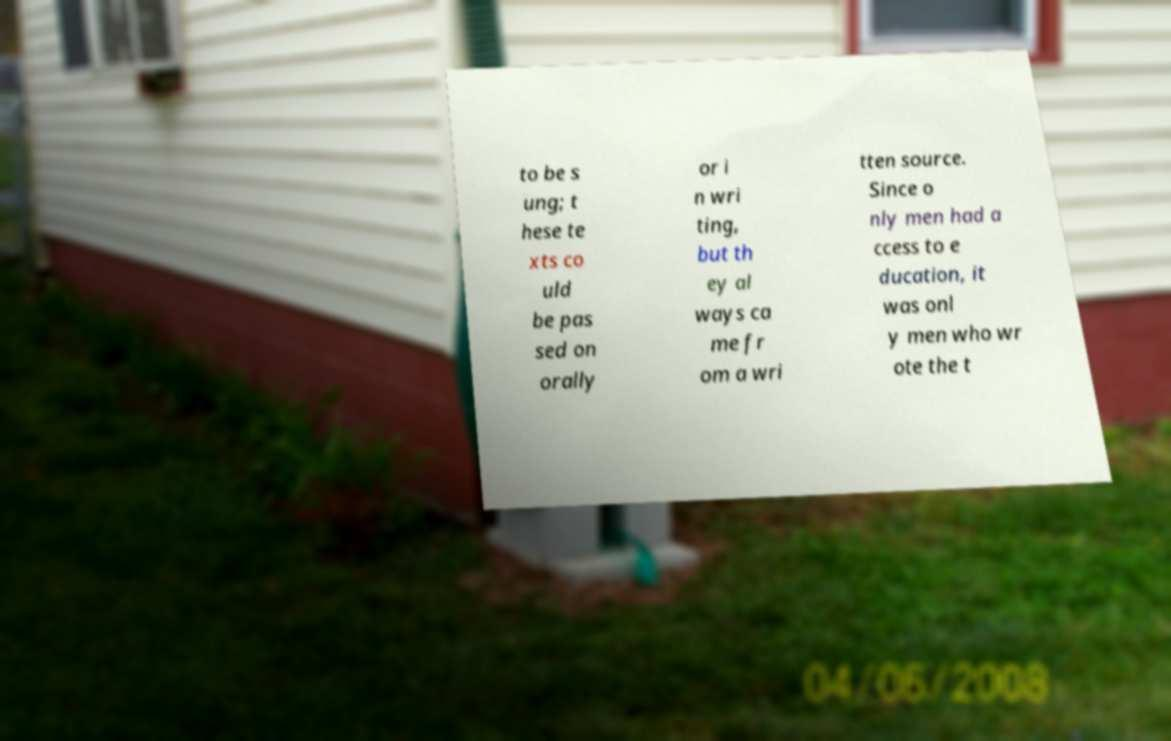Can you accurately transcribe the text from the provided image for me? to be s ung; t hese te xts co uld be pas sed on orally or i n wri ting, but th ey al ways ca me fr om a wri tten source. Since o nly men had a ccess to e ducation, it was onl y men who wr ote the t 